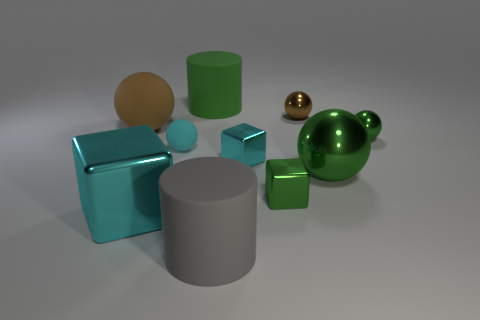What can the reflections and shadows tell us about the lighting in this scene? The reflections on the surfaces of the objects indicate a primary light source located out of the frame, casting light diagonally across the scene. This creates sharp, defined shadows on the ground, suggesting the light source is strong and possibly directional, similar to sunlight or a focused artificial light. The way the light reflects and the shadows are cast provides depth to the image and highlights the objects' textures and material qualities. 